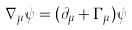Convert formula to latex. <formula><loc_0><loc_0><loc_500><loc_500>\nabla _ { \mu } \psi = ( \partial _ { \mu } + \Gamma _ { \mu } ) \psi</formula> 